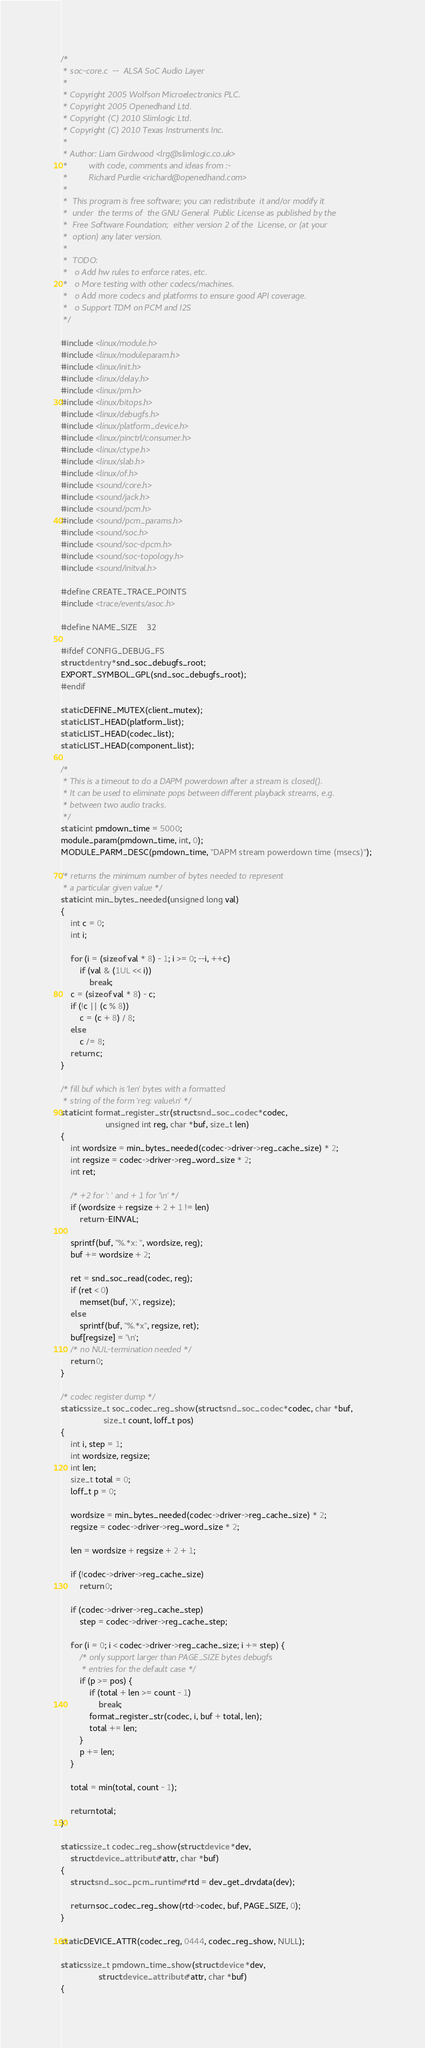<code> <loc_0><loc_0><loc_500><loc_500><_C_>/*
 * soc-core.c  --  ALSA SoC Audio Layer
 *
 * Copyright 2005 Wolfson Microelectronics PLC.
 * Copyright 2005 Openedhand Ltd.
 * Copyright (C) 2010 Slimlogic Ltd.
 * Copyright (C) 2010 Texas Instruments Inc.
 *
 * Author: Liam Girdwood <lrg@slimlogic.co.uk>
 *         with code, comments and ideas from :-
 *         Richard Purdie <richard@openedhand.com>
 *
 *  This program is free software; you can redistribute  it and/or modify it
 *  under  the terms of  the GNU General  Public License as published by the
 *  Free Software Foundation;  either version 2 of the  License, or (at your
 *  option) any later version.
 *
 *  TODO:
 *   o Add hw rules to enforce rates, etc.
 *   o More testing with other codecs/machines.
 *   o Add more codecs and platforms to ensure good API coverage.
 *   o Support TDM on PCM and I2S
 */

#include <linux/module.h>
#include <linux/moduleparam.h>
#include <linux/init.h>
#include <linux/delay.h>
#include <linux/pm.h>
#include <linux/bitops.h>
#include <linux/debugfs.h>
#include <linux/platform_device.h>
#include <linux/pinctrl/consumer.h>
#include <linux/ctype.h>
#include <linux/slab.h>
#include <linux/of.h>
#include <sound/core.h>
#include <sound/jack.h>
#include <sound/pcm.h>
#include <sound/pcm_params.h>
#include <sound/soc.h>
#include <sound/soc-dpcm.h>
#include <sound/soc-topology.h>
#include <sound/initval.h>

#define CREATE_TRACE_POINTS
#include <trace/events/asoc.h>

#define NAME_SIZE	32

#ifdef CONFIG_DEBUG_FS
struct dentry *snd_soc_debugfs_root;
EXPORT_SYMBOL_GPL(snd_soc_debugfs_root);
#endif

static DEFINE_MUTEX(client_mutex);
static LIST_HEAD(platform_list);
static LIST_HEAD(codec_list);
static LIST_HEAD(component_list);

/*
 * This is a timeout to do a DAPM powerdown after a stream is closed().
 * It can be used to eliminate pops between different playback streams, e.g.
 * between two audio tracks.
 */
static int pmdown_time = 5000;
module_param(pmdown_time, int, 0);
MODULE_PARM_DESC(pmdown_time, "DAPM stream powerdown time (msecs)");

/* returns the minimum number of bytes needed to represent
 * a particular given value */
static int min_bytes_needed(unsigned long val)
{
	int c = 0;
	int i;

	for (i = (sizeof val * 8) - 1; i >= 0; --i, ++c)
		if (val & (1UL << i))
			break;
	c = (sizeof val * 8) - c;
	if (!c || (c % 8))
		c = (c + 8) / 8;
	else
		c /= 8;
	return c;
}

/* fill buf which is 'len' bytes with a formatted
 * string of the form 'reg: value\n' */
static int format_register_str(struct snd_soc_codec *codec,
			       unsigned int reg, char *buf, size_t len)
{
	int wordsize = min_bytes_needed(codec->driver->reg_cache_size) * 2;
	int regsize = codec->driver->reg_word_size * 2;
	int ret;

	/* +2 for ': ' and + 1 for '\n' */
	if (wordsize + regsize + 2 + 1 != len)
		return -EINVAL;

	sprintf(buf, "%.*x: ", wordsize, reg);
	buf += wordsize + 2;

	ret = snd_soc_read(codec, reg);
	if (ret < 0)
		memset(buf, 'X', regsize);
	else
		sprintf(buf, "%.*x", regsize, ret);
	buf[regsize] = '\n';
	/* no NUL-termination needed */
	return 0;
}

/* codec register dump */
static ssize_t soc_codec_reg_show(struct snd_soc_codec *codec, char *buf,
				  size_t count, loff_t pos)
{
	int i, step = 1;
	int wordsize, regsize;
	int len;
	size_t total = 0;
	loff_t p = 0;

	wordsize = min_bytes_needed(codec->driver->reg_cache_size) * 2;
	regsize = codec->driver->reg_word_size * 2;

	len = wordsize + regsize + 2 + 1;

	if (!codec->driver->reg_cache_size)
		return 0;

	if (codec->driver->reg_cache_step)
		step = codec->driver->reg_cache_step;

	for (i = 0; i < codec->driver->reg_cache_size; i += step) {
		/* only support larger than PAGE_SIZE bytes debugfs
		 * entries for the default case */
		if (p >= pos) {
			if (total + len >= count - 1)
				break;
			format_register_str(codec, i, buf + total, len);
			total += len;
		}
		p += len;
	}

	total = min(total, count - 1);

	return total;
}

static ssize_t codec_reg_show(struct device *dev,
	struct device_attribute *attr, char *buf)
{
	struct snd_soc_pcm_runtime *rtd = dev_get_drvdata(dev);

	return soc_codec_reg_show(rtd->codec, buf, PAGE_SIZE, 0);
}

static DEVICE_ATTR(codec_reg, 0444, codec_reg_show, NULL);

static ssize_t pmdown_time_show(struct device *dev,
				struct device_attribute *attr, char *buf)
{</code> 